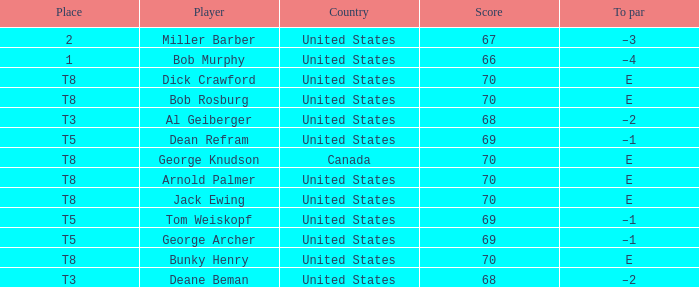Which country is George Archer from? United States. 